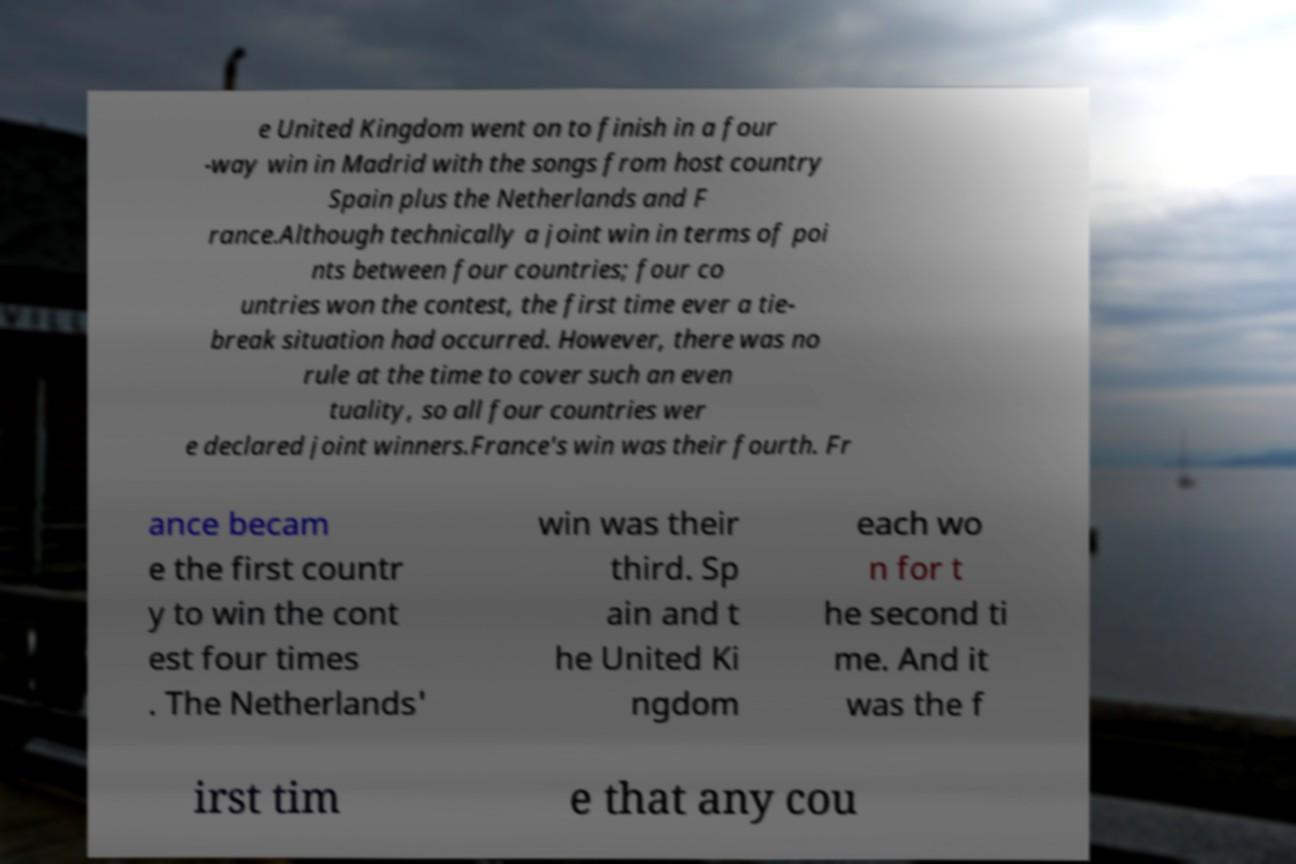Could you extract and type out the text from this image? e United Kingdom went on to finish in a four -way win in Madrid with the songs from host country Spain plus the Netherlands and F rance.Although technically a joint win in terms of poi nts between four countries; four co untries won the contest, the first time ever a tie- break situation had occurred. However, there was no rule at the time to cover such an even tuality, so all four countries wer e declared joint winners.France's win was their fourth. Fr ance becam e the first countr y to win the cont est four times . The Netherlands' win was their third. Sp ain and t he United Ki ngdom each wo n for t he second ti me. And it was the f irst tim e that any cou 